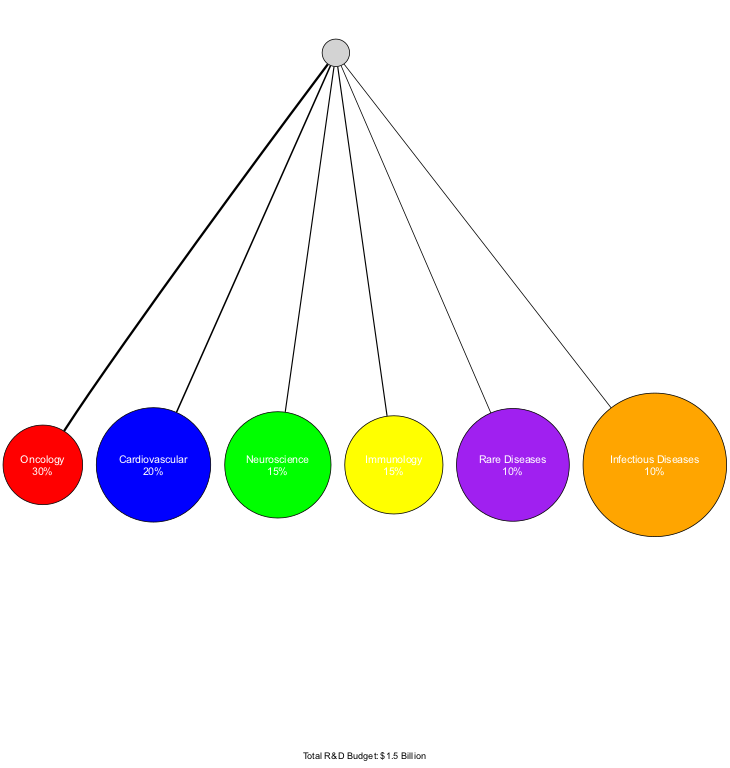What percentage of the R&D budget is allocated to oncology? The pie chart indicates that oncology has a percentage label of 30%. This is derived from the data point representing oncology in the diagram.
Answer: 30% How many therapeutic areas are represented in the diagram? The diagram includes six distinct therapeutic areas: Oncology, Cardiovascular, Neuroscience, Immunology, Rare Diseases, and Infectious Diseases. Counting these areas gives a total of 6.
Answer: 6 Which therapeutic area has the smallest budget allocation? By comparing the percentage allocations, Rare Diseases and Infectious Diseases both receive 10%, which is the lowest among the areas represented.
Answer: Rare Diseases (and Infectious Diseases) What is the total R&D budget as noted in the diagram? The note in the diagram states that the total R&D budget is $1.5 Billion. This is the total amount allocated across all represented therapeutic areas.
Answer: $1.5 Billion Which therapeutic area has a larger budget allocation, Immunology or Neuroscience? The percentages indicate that Immunology and Neuroscience both have 15% allocations. Therefore, they are equal, and neither has a larger budget.
Answer: Equal What color represents Cardiovascular in the chart? The visual diagram assigns blue to Cardiovascular. This color coding is found in the color list provided for the chart.
Answer: Blue What percentage of the R&D budget is represented by infectious diseases? The diagram shows that infectious diseases have a percentage label of 10%. This value is clearly indicated on the corresponding node in the pie chart.
Answer: 10% Among the therapeutic areas, which one is allocated the highest percentage of the budget? Oncology is allocated the highest percentage at 30%. This can be confirmed by comparing the percentages of all areas in the chart.
Answer: Oncology How many times more budget is allocated to Oncology compared to Rare Diseases? Oncology receives 30% while Rare Diseases receives 10%. This indicates that the allocation for Oncology is three times that for Rare Diseases (30 divided by 10 equals 3).
Answer: 3 times 